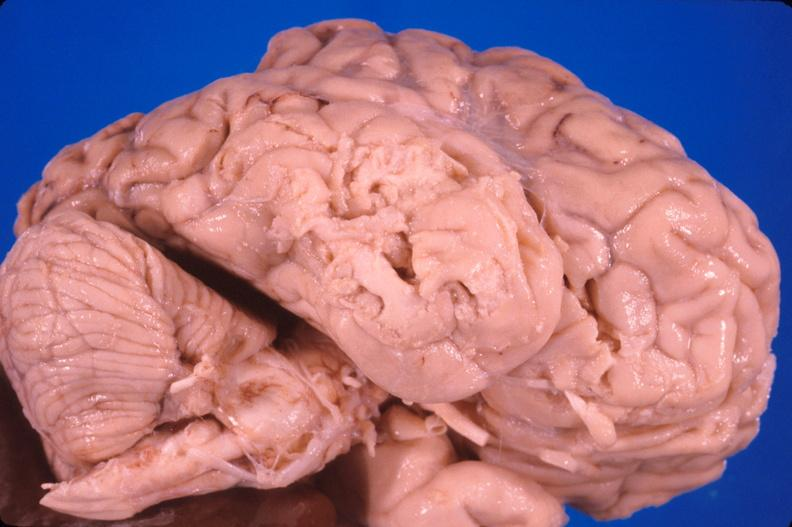s newborn cord around neck present?
Answer the question using a single word or phrase. No 